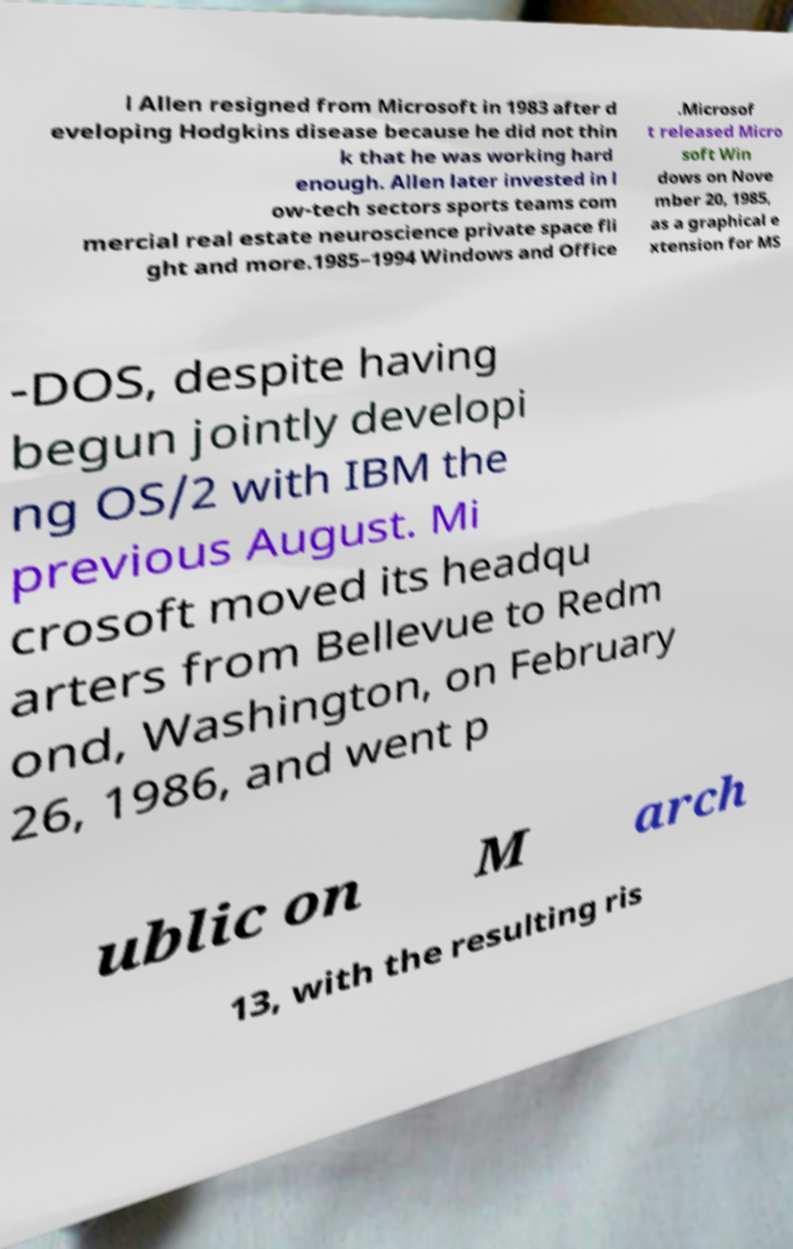Could you assist in decoding the text presented in this image and type it out clearly? l Allen resigned from Microsoft in 1983 after d eveloping Hodgkins disease because he did not thin k that he was working hard enough. Allen later invested in l ow-tech sectors sports teams com mercial real estate neuroscience private space fli ght and more.1985–1994 Windows and Office .Microsof t released Micro soft Win dows on Nove mber 20, 1985, as a graphical e xtension for MS -DOS, despite having begun jointly developi ng OS/2 with IBM the previous August. Mi crosoft moved its headqu arters from Bellevue to Redm ond, Washington, on February 26, 1986, and went p ublic on M arch 13, with the resulting ris 